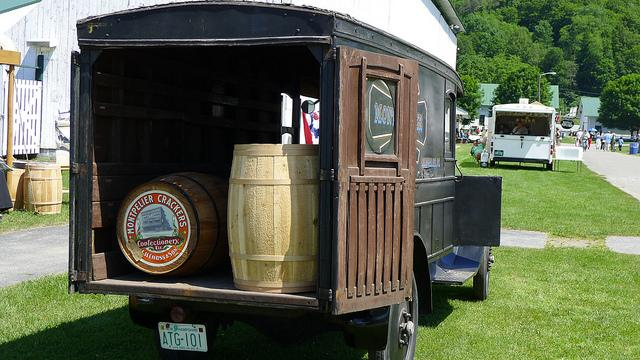What type of labeling is on the barrel?

Choices:
A) brand
B) regulatory
C) warning
D) directional brand 